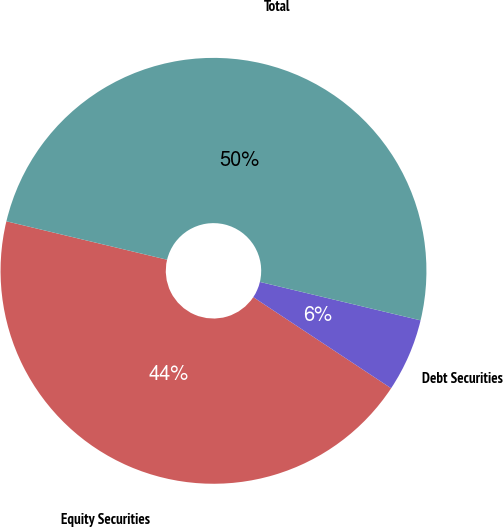Convert chart to OTSL. <chart><loc_0><loc_0><loc_500><loc_500><pie_chart><fcel>Equity Securities<fcel>Debt Securities<fcel>Total<nl><fcel>44.44%<fcel>5.56%<fcel>50.0%<nl></chart> 